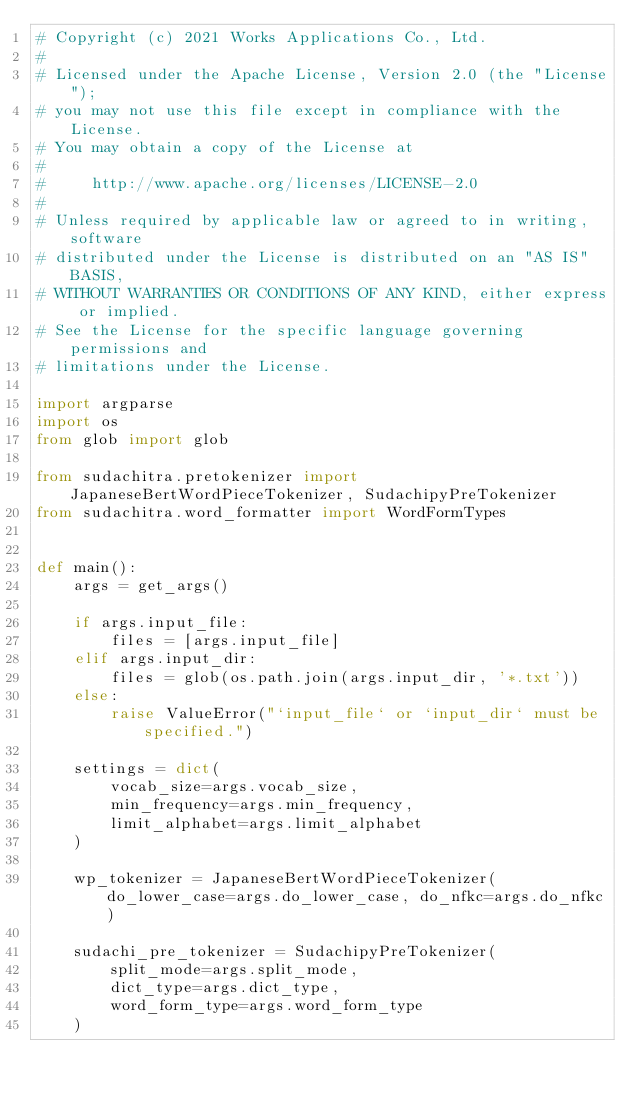<code> <loc_0><loc_0><loc_500><loc_500><_Python_># Copyright (c) 2021 Works Applications Co., Ltd.
#
# Licensed under the Apache License, Version 2.0 (the "License");
# you may not use this file except in compliance with the License.
# You may obtain a copy of the License at
#
#     http://www.apache.org/licenses/LICENSE-2.0
#
# Unless required by applicable law or agreed to in writing, software
# distributed under the License is distributed on an "AS IS" BASIS,
# WITHOUT WARRANTIES OR CONDITIONS OF ANY KIND, either express or implied.
# See the License for the specific language governing permissions and
# limitations under the License.

import argparse
import os
from glob import glob

from sudachitra.pretokenizer import JapaneseBertWordPieceTokenizer, SudachipyPreTokenizer
from sudachitra.word_formatter import WordFormTypes


def main():
    args = get_args()

    if args.input_file:
        files = [args.input_file]
    elif args.input_dir:
        files = glob(os.path.join(args.input_dir, '*.txt'))
    else:
        raise ValueError("`input_file` or `input_dir` must be specified.")

    settings = dict(
        vocab_size=args.vocab_size,
        min_frequency=args.min_frequency,
        limit_alphabet=args.limit_alphabet
    )

    wp_tokenizer = JapaneseBertWordPieceTokenizer(do_lower_case=args.do_lower_case, do_nfkc=args.do_nfkc)

    sudachi_pre_tokenizer = SudachipyPreTokenizer(
        split_mode=args.split_mode,
        dict_type=args.dict_type,
        word_form_type=args.word_form_type
    )</code> 